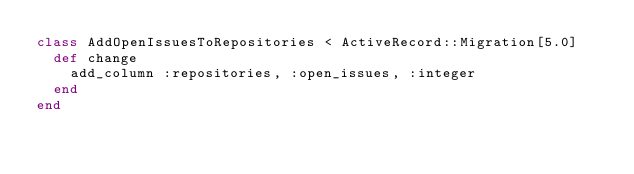Convert code to text. <code><loc_0><loc_0><loc_500><loc_500><_Ruby_>class AddOpenIssuesToRepositories < ActiveRecord::Migration[5.0]
  def change
    add_column :repositories, :open_issues, :integer
  end
end
</code> 